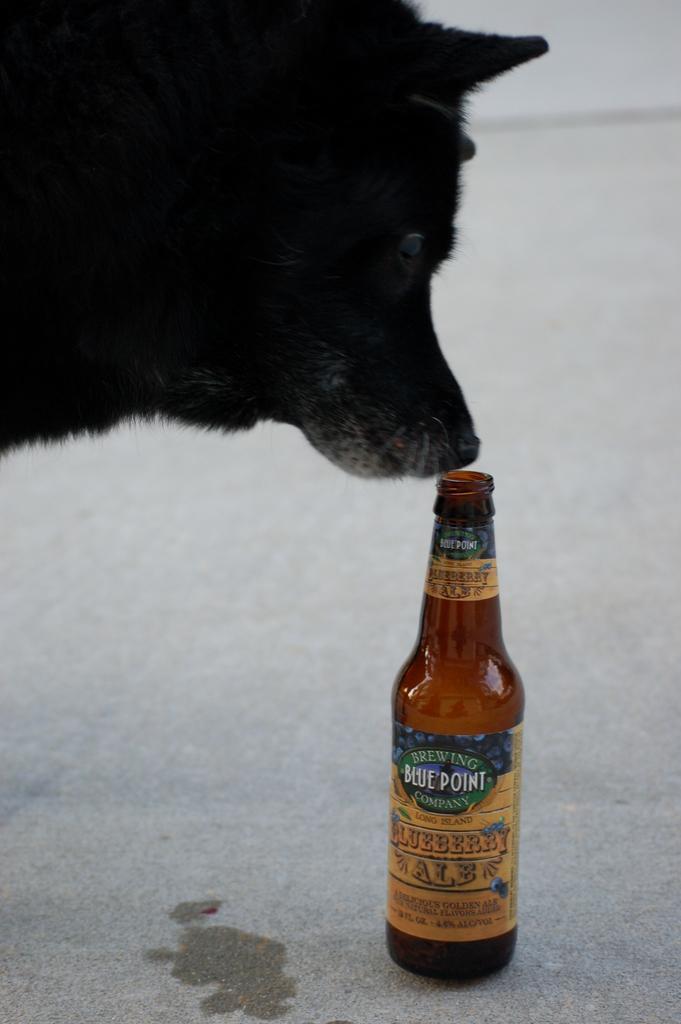Describe this image in one or two sentences. In this picture we can see a black color dog and a bottle on the ground. 